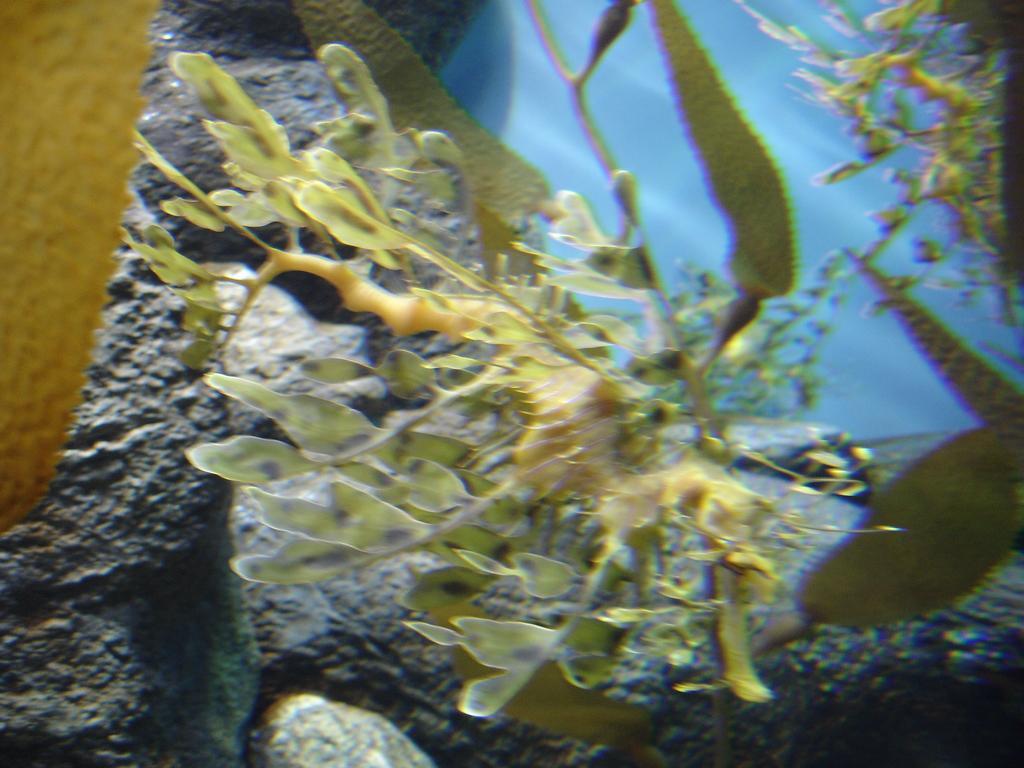Can you describe this image briefly? In this image we can see there is a plant and rocks. And at the side, it looks like a water. 